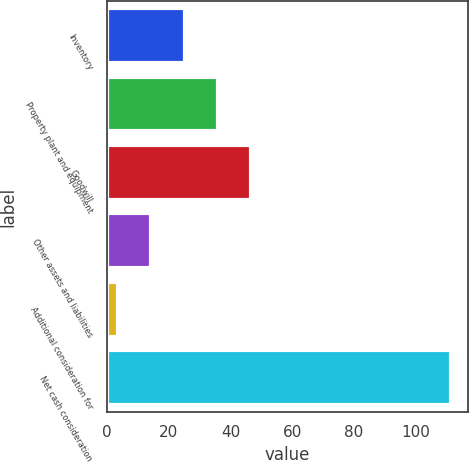<chart> <loc_0><loc_0><loc_500><loc_500><bar_chart><fcel>Inventory<fcel>Property plant and equipment<fcel>Goodwill<fcel>Other assets and liabilities<fcel>Additional consideration for<fcel>Net cash consideration<nl><fcel>25.14<fcel>35.91<fcel>46.68<fcel>14.37<fcel>3.6<fcel>111.3<nl></chart> 